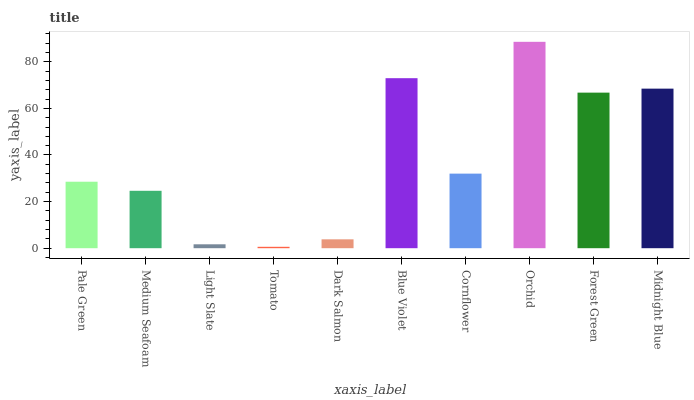Is Tomato the minimum?
Answer yes or no. Yes. Is Orchid the maximum?
Answer yes or no. Yes. Is Medium Seafoam the minimum?
Answer yes or no. No. Is Medium Seafoam the maximum?
Answer yes or no. No. Is Pale Green greater than Medium Seafoam?
Answer yes or no. Yes. Is Medium Seafoam less than Pale Green?
Answer yes or no. Yes. Is Medium Seafoam greater than Pale Green?
Answer yes or no. No. Is Pale Green less than Medium Seafoam?
Answer yes or no. No. Is Cornflower the high median?
Answer yes or no. Yes. Is Pale Green the low median?
Answer yes or no. Yes. Is Forest Green the high median?
Answer yes or no. No. Is Forest Green the low median?
Answer yes or no. No. 